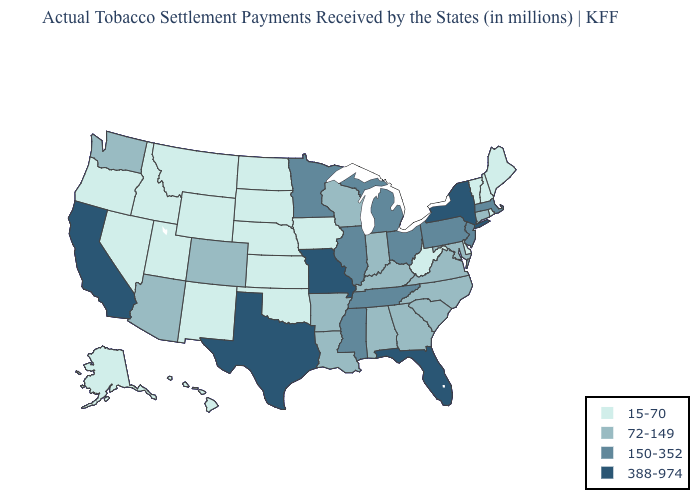What is the lowest value in the USA?
Be succinct. 15-70. Which states have the lowest value in the USA?
Write a very short answer. Alaska, Delaware, Hawaii, Idaho, Iowa, Kansas, Maine, Montana, Nebraska, Nevada, New Hampshire, New Mexico, North Dakota, Oklahoma, Oregon, Rhode Island, South Dakota, Utah, Vermont, West Virginia, Wyoming. Among the states that border Iowa , which have the lowest value?
Short answer required. Nebraska, South Dakota. Name the states that have a value in the range 150-352?
Answer briefly. Illinois, Massachusetts, Michigan, Minnesota, Mississippi, New Jersey, Ohio, Pennsylvania, Tennessee. Among the states that border California , does Arizona have the lowest value?
Give a very brief answer. No. Which states have the highest value in the USA?
Give a very brief answer. California, Florida, Missouri, New York, Texas. Which states have the highest value in the USA?
Give a very brief answer. California, Florida, Missouri, New York, Texas. Name the states that have a value in the range 388-974?
Concise answer only. California, Florida, Missouri, New York, Texas. Does Maine have a lower value than Illinois?
Write a very short answer. Yes. What is the lowest value in the MidWest?
Short answer required. 15-70. Name the states that have a value in the range 150-352?
Short answer required. Illinois, Massachusetts, Michigan, Minnesota, Mississippi, New Jersey, Ohio, Pennsylvania, Tennessee. Name the states that have a value in the range 15-70?
Give a very brief answer. Alaska, Delaware, Hawaii, Idaho, Iowa, Kansas, Maine, Montana, Nebraska, Nevada, New Hampshire, New Mexico, North Dakota, Oklahoma, Oregon, Rhode Island, South Dakota, Utah, Vermont, West Virginia, Wyoming. Does Tennessee have a higher value than Kansas?
Answer briefly. Yes. How many symbols are there in the legend?
Write a very short answer. 4. What is the lowest value in the USA?
Keep it brief. 15-70. 